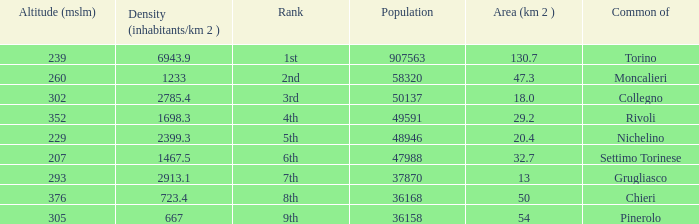How many altitudes does the common with an area of 130.7 km^2 have? 1.0. 